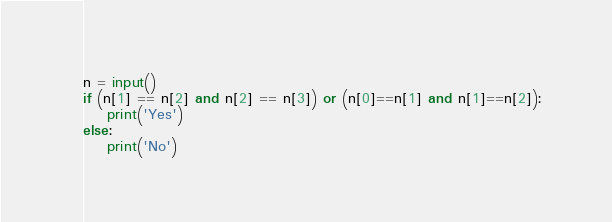Convert code to text. <code><loc_0><loc_0><loc_500><loc_500><_Python_>n = input()
if (n[1] == n[2] and n[2] == n[3]) or (n[0]==n[1] and n[1]==n[2]):
    print('Yes')
else:
    print('No')</code> 